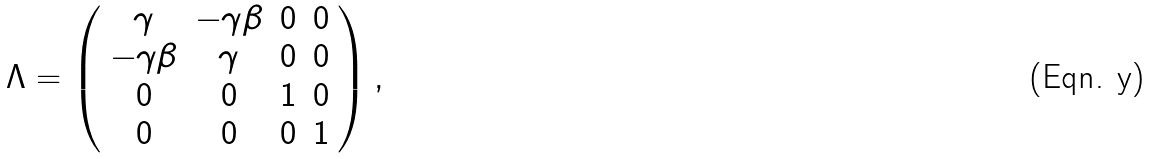<formula> <loc_0><loc_0><loc_500><loc_500>\Lambda = \left ( \begin{array} { c c c c } \gamma & - \gamma \beta & 0 & 0 \\ - \gamma \beta & \gamma & 0 & 0 \\ 0 & 0 & 1 & 0 \\ 0 & 0 & 0 & 1 \end{array} \right ) ,</formula> 